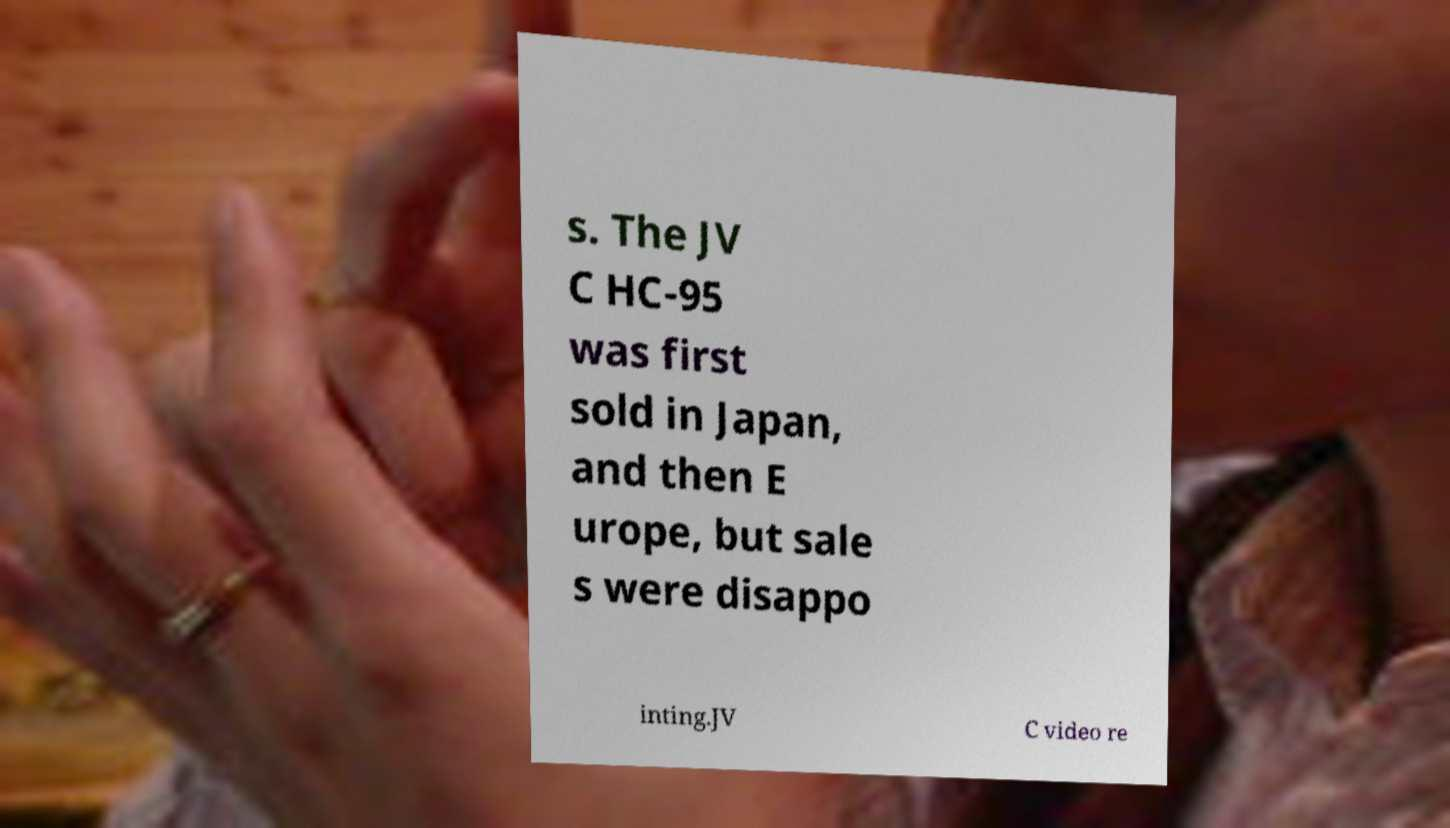Can you read and provide the text displayed in the image?This photo seems to have some interesting text. Can you extract and type it out for me? s. The JV C HC-95 was first sold in Japan, and then E urope, but sale s were disappo inting.JV C video re 